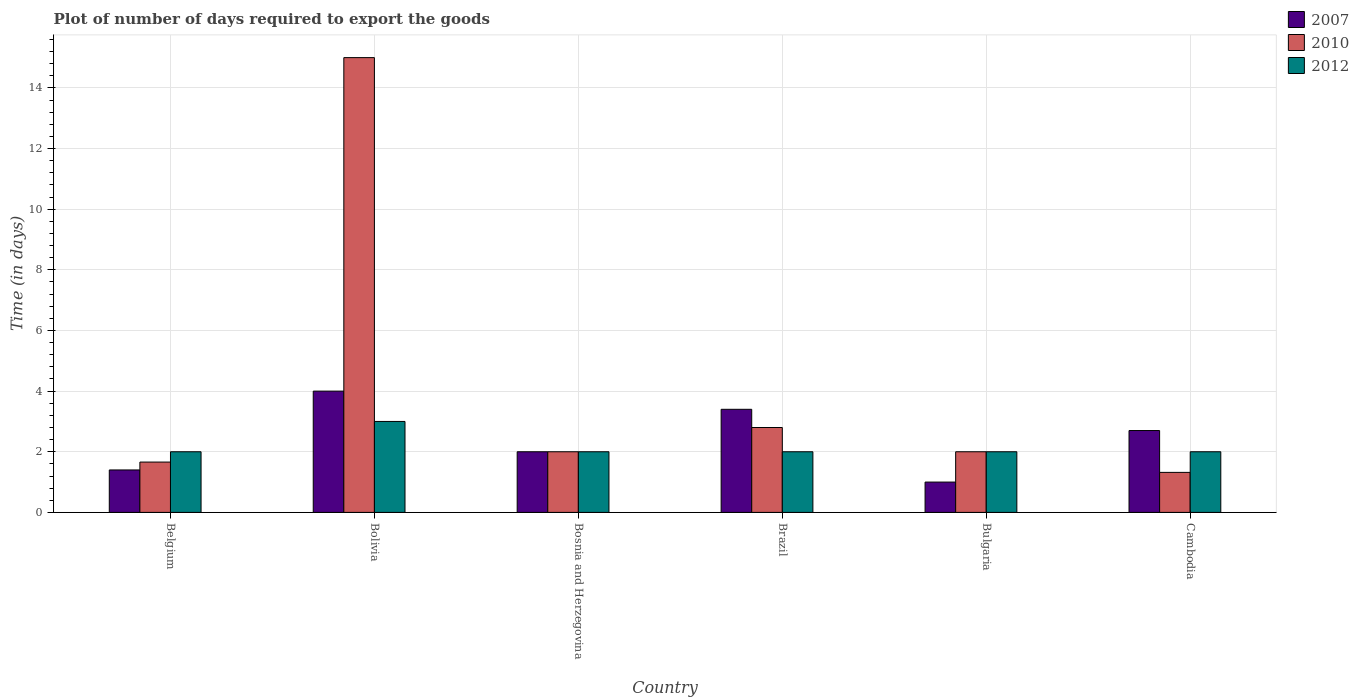Are the number of bars per tick equal to the number of legend labels?
Your answer should be compact. Yes. How many bars are there on the 5th tick from the right?
Give a very brief answer. 3. In how many cases, is the number of bars for a given country not equal to the number of legend labels?
Your answer should be very brief. 0. In which country was the time required to export goods in 2012 maximum?
Your answer should be very brief. Bolivia. In which country was the time required to export goods in 2007 minimum?
Keep it short and to the point. Bulgaria. What is the total time required to export goods in 2007 in the graph?
Your answer should be very brief. 14.5. What is the difference between the time required to export goods in 2012 in Belgium and that in Bolivia?
Provide a short and direct response. -1. What is the difference between the time required to export goods in 2007 in Cambodia and the time required to export goods in 2012 in Bulgaria?
Offer a very short reply. 0.7. What is the average time required to export goods in 2012 per country?
Your answer should be compact. 2.17. What is the difference between the time required to export goods of/in 2010 and time required to export goods of/in 2012 in Cambodia?
Offer a very short reply. -0.68. In how many countries, is the time required to export goods in 2010 greater than 2.8 days?
Make the answer very short. 1. What is the ratio of the time required to export goods in 2010 in Belgium to that in Bulgaria?
Your answer should be very brief. 0.83. Is the time required to export goods in 2007 in Belgium less than that in Bolivia?
Your answer should be compact. Yes. What is the difference between the highest and the lowest time required to export goods in 2010?
Make the answer very short. 13.68. Is the sum of the time required to export goods in 2012 in Bolivia and Brazil greater than the maximum time required to export goods in 2007 across all countries?
Your answer should be very brief. Yes. What does the 1st bar from the left in Bulgaria represents?
Offer a very short reply. 2007. What does the 3rd bar from the right in Bosnia and Herzegovina represents?
Your answer should be very brief. 2007. How many countries are there in the graph?
Ensure brevity in your answer.  6. What is the difference between two consecutive major ticks on the Y-axis?
Your response must be concise. 2. Are the values on the major ticks of Y-axis written in scientific E-notation?
Provide a succinct answer. No. Does the graph contain grids?
Provide a succinct answer. Yes. Where does the legend appear in the graph?
Offer a terse response. Top right. What is the title of the graph?
Offer a very short reply. Plot of number of days required to export the goods. Does "1967" appear as one of the legend labels in the graph?
Provide a succinct answer. No. What is the label or title of the X-axis?
Your response must be concise. Country. What is the label or title of the Y-axis?
Offer a terse response. Time (in days). What is the Time (in days) in 2007 in Belgium?
Your answer should be very brief. 1.4. What is the Time (in days) in 2010 in Belgium?
Your response must be concise. 1.66. What is the Time (in days) in 2012 in Belgium?
Ensure brevity in your answer.  2. What is the Time (in days) of 2007 in Bolivia?
Offer a terse response. 4. What is the Time (in days) of 2012 in Bolivia?
Provide a succinct answer. 3. What is the Time (in days) in 2007 in Brazil?
Give a very brief answer. 3.4. What is the Time (in days) of 2010 in Brazil?
Your answer should be very brief. 2.8. What is the Time (in days) of 2012 in Brazil?
Provide a short and direct response. 2. What is the Time (in days) of 2010 in Bulgaria?
Provide a short and direct response. 2. What is the Time (in days) in 2012 in Bulgaria?
Your answer should be compact. 2. What is the Time (in days) in 2007 in Cambodia?
Offer a terse response. 2.7. What is the Time (in days) in 2010 in Cambodia?
Your response must be concise. 1.32. What is the Time (in days) in 2012 in Cambodia?
Your answer should be compact. 2. Across all countries, what is the maximum Time (in days) of 2010?
Your answer should be very brief. 15. Across all countries, what is the minimum Time (in days) of 2010?
Provide a short and direct response. 1.32. Across all countries, what is the minimum Time (in days) of 2012?
Keep it short and to the point. 2. What is the total Time (in days) in 2007 in the graph?
Your answer should be very brief. 14.5. What is the total Time (in days) in 2010 in the graph?
Your answer should be compact. 24.78. What is the difference between the Time (in days) of 2007 in Belgium and that in Bolivia?
Make the answer very short. -2.6. What is the difference between the Time (in days) of 2010 in Belgium and that in Bolivia?
Ensure brevity in your answer.  -13.34. What is the difference between the Time (in days) in 2012 in Belgium and that in Bolivia?
Make the answer very short. -1. What is the difference between the Time (in days) in 2007 in Belgium and that in Bosnia and Herzegovina?
Ensure brevity in your answer.  -0.6. What is the difference between the Time (in days) of 2010 in Belgium and that in Bosnia and Herzegovina?
Keep it short and to the point. -0.34. What is the difference between the Time (in days) in 2010 in Belgium and that in Brazil?
Give a very brief answer. -1.14. What is the difference between the Time (in days) in 2010 in Belgium and that in Bulgaria?
Give a very brief answer. -0.34. What is the difference between the Time (in days) in 2010 in Belgium and that in Cambodia?
Give a very brief answer. 0.34. What is the difference between the Time (in days) in 2012 in Belgium and that in Cambodia?
Your answer should be compact. 0. What is the difference between the Time (in days) in 2007 in Bolivia and that in Bosnia and Herzegovina?
Your answer should be very brief. 2. What is the difference between the Time (in days) of 2010 in Bolivia and that in Bosnia and Herzegovina?
Offer a terse response. 13. What is the difference between the Time (in days) of 2007 in Bolivia and that in Brazil?
Make the answer very short. 0.6. What is the difference between the Time (in days) of 2010 in Bolivia and that in Brazil?
Your answer should be compact. 12.2. What is the difference between the Time (in days) of 2010 in Bolivia and that in Cambodia?
Your answer should be compact. 13.68. What is the difference between the Time (in days) of 2012 in Bolivia and that in Cambodia?
Provide a succinct answer. 1. What is the difference between the Time (in days) in 2010 in Bosnia and Herzegovina and that in Brazil?
Keep it short and to the point. -0.8. What is the difference between the Time (in days) of 2010 in Bosnia and Herzegovina and that in Cambodia?
Make the answer very short. 0.68. What is the difference between the Time (in days) in 2012 in Bosnia and Herzegovina and that in Cambodia?
Provide a short and direct response. 0. What is the difference between the Time (in days) of 2010 in Brazil and that in Bulgaria?
Offer a very short reply. 0.8. What is the difference between the Time (in days) in 2012 in Brazil and that in Bulgaria?
Provide a succinct answer. 0. What is the difference between the Time (in days) in 2010 in Brazil and that in Cambodia?
Your answer should be very brief. 1.48. What is the difference between the Time (in days) of 2007 in Bulgaria and that in Cambodia?
Your answer should be very brief. -1.7. What is the difference between the Time (in days) of 2010 in Bulgaria and that in Cambodia?
Provide a short and direct response. 0.68. What is the difference between the Time (in days) in 2010 in Belgium and the Time (in days) in 2012 in Bolivia?
Ensure brevity in your answer.  -1.34. What is the difference between the Time (in days) in 2007 in Belgium and the Time (in days) in 2010 in Bosnia and Herzegovina?
Offer a terse response. -0.6. What is the difference between the Time (in days) of 2007 in Belgium and the Time (in days) of 2012 in Bosnia and Herzegovina?
Your response must be concise. -0.6. What is the difference between the Time (in days) of 2010 in Belgium and the Time (in days) of 2012 in Bosnia and Herzegovina?
Make the answer very short. -0.34. What is the difference between the Time (in days) in 2010 in Belgium and the Time (in days) in 2012 in Brazil?
Give a very brief answer. -0.34. What is the difference between the Time (in days) of 2010 in Belgium and the Time (in days) of 2012 in Bulgaria?
Provide a short and direct response. -0.34. What is the difference between the Time (in days) in 2010 in Belgium and the Time (in days) in 2012 in Cambodia?
Make the answer very short. -0.34. What is the difference between the Time (in days) of 2007 in Bolivia and the Time (in days) of 2010 in Bosnia and Herzegovina?
Give a very brief answer. 2. What is the difference between the Time (in days) of 2007 in Bolivia and the Time (in days) of 2012 in Bosnia and Herzegovina?
Ensure brevity in your answer.  2. What is the difference between the Time (in days) in 2007 in Bolivia and the Time (in days) in 2012 in Brazil?
Offer a terse response. 2. What is the difference between the Time (in days) of 2010 in Bolivia and the Time (in days) of 2012 in Brazil?
Provide a succinct answer. 13. What is the difference between the Time (in days) of 2007 in Bolivia and the Time (in days) of 2010 in Cambodia?
Give a very brief answer. 2.68. What is the difference between the Time (in days) of 2007 in Bolivia and the Time (in days) of 2012 in Cambodia?
Your answer should be very brief. 2. What is the difference between the Time (in days) in 2010 in Bolivia and the Time (in days) in 2012 in Cambodia?
Give a very brief answer. 13. What is the difference between the Time (in days) of 2010 in Bosnia and Herzegovina and the Time (in days) of 2012 in Brazil?
Make the answer very short. 0. What is the difference between the Time (in days) of 2010 in Bosnia and Herzegovina and the Time (in days) of 2012 in Bulgaria?
Provide a succinct answer. 0. What is the difference between the Time (in days) in 2007 in Bosnia and Herzegovina and the Time (in days) in 2010 in Cambodia?
Keep it short and to the point. 0.68. What is the difference between the Time (in days) of 2007 in Brazil and the Time (in days) of 2010 in Bulgaria?
Your answer should be compact. 1.4. What is the difference between the Time (in days) of 2010 in Brazil and the Time (in days) of 2012 in Bulgaria?
Your answer should be very brief. 0.8. What is the difference between the Time (in days) in 2007 in Brazil and the Time (in days) in 2010 in Cambodia?
Your answer should be very brief. 2.08. What is the difference between the Time (in days) of 2010 in Brazil and the Time (in days) of 2012 in Cambodia?
Offer a very short reply. 0.8. What is the difference between the Time (in days) of 2007 in Bulgaria and the Time (in days) of 2010 in Cambodia?
Provide a short and direct response. -0.32. What is the average Time (in days) in 2007 per country?
Give a very brief answer. 2.42. What is the average Time (in days) of 2010 per country?
Offer a terse response. 4.13. What is the average Time (in days) in 2012 per country?
Provide a short and direct response. 2.17. What is the difference between the Time (in days) in 2007 and Time (in days) in 2010 in Belgium?
Make the answer very short. -0.26. What is the difference between the Time (in days) of 2010 and Time (in days) of 2012 in Belgium?
Make the answer very short. -0.34. What is the difference between the Time (in days) in 2007 and Time (in days) in 2010 in Bolivia?
Offer a very short reply. -11. What is the difference between the Time (in days) in 2007 and Time (in days) in 2010 in Bosnia and Herzegovina?
Keep it short and to the point. 0. What is the difference between the Time (in days) in 2007 and Time (in days) in 2012 in Bosnia and Herzegovina?
Offer a very short reply. 0. What is the difference between the Time (in days) in 2010 and Time (in days) in 2012 in Brazil?
Ensure brevity in your answer.  0.8. What is the difference between the Time (in days) in 2007 and Time (in days) in 2010 in Bulgaria?
Offer a terse response. -1. What is the difference between the Time (in days) of 2007 and Time (in days) of 2012 in Bulgaria?
Provide a succinct answer. -1. What is the difference between the Time (in days) in 2007 and Time (in days) in 2010 in Cambodia?
Your response must be concise. 1.38. What is the difference between the Time (in days) of 2007 and Time (in days) of 2012 in Cambodia?
Your answer should be compact. 0.7. What is the difference between the Time (in days) in 2010 and Time (in days) in 2012 in Cambodia?
Provide a succinct answer. -0.68. What is the ratio of the Time (in days) of 2007 in Belgium to that in Bolivia?
Your response must be concise. 0.35. What is the ratio of the Time (in days) in 2010 in Belgium to that in Bolivia?
Provide a short and direct response. 0.11. What is the ratio of the Time (in days) in 2012 in Belgium to that in Bolivia?
Offer a very short reply. 0.67. What is the ratio of the Time (in days) of 2010 in Belgium to that in Bosnia and Herzegovina?
Provide a short and direct response. 0.83. What is the ratio of the Time (in days) of 2012 in Belgium to that in Bosnia and Herzegovina?
Give a very brief answer. 1. What is the ratio of the Time (in days) in 2007 in Belgium to that in Brazil?
Give a very brief answer. 0.41. What is the ratio of the Time (in days) of 2010 in Belgium to that in Brazil?
Give a very brief answer. 0.59. What is the ratio of the Time (in days) of 2010 in Belgium to that in Bulgaria?
Give a very brief answer. 0.83. What is the ratio of the Time (in days) in 2012 in Belgium to that in Bulgaria?
Offer a very short reply. 1. What is the ratio of the Time (in days) in 2007 in Belgium to that in Cambodia?
Offer a very short reply. 0.52. What is the ratio of the Time (in days) in 2010 in Belgium to that in Cambodia?
Make the answer very short. 1.26. What is the ratio of the Time (in days) in 2012 in Belgium to that in Cambodia?
Your response must be concise. 1. What is the ratio of the Time (in days) in 2007 in Bolivia to that in Bosnia and Herzegovina?
Provide a short and direct response. 2. What is the ratio of the Time (in days) of 2012 in Bolivia to that in Bosnia and Herzegovina?
Provide a succinct answer. 1.5. What is the ratio of the Time (in days) in 2007 in Bolivia to that in Brazil?
Give a very brief answer. 1.18. What is the ratio of the Time (in days) of 2010 in Bolivia to that in Brazil?
Ensure brevity in your answer.  5.36. What is the ratio of the Time (in days) of 2012 in Bolivia to that in Brazil?
Make the answer very short. 1.5. What is the ratio of the Time (in days) in 2007 in Bolivia to that in Bulgaria?
Your answer should be very brief. 4. What is the ratio of the Time (in days) of 2010 in Bolivia to that in Bulgaria?
Your answer should be very brief. 7.5. What is the ratio of the Time (in days) of 2012 in Bolivia to that in Bulgaria?
Make the answer very short. 1.5. What is the ratio of the Time (in days) in 2007 in Bolivia to that in Cambodia?
Offer a terse response. 1.48. What is the ratio of the Time (in days) of 2010 in Bolivia to that in Cambodia?
Offer a very short reply. 11.36. What is the ratio of the Time (in days) of 2007 in Bosnia and Herzegovina to that in Brazil?
Provide a short and direct response. 0.59. What is the ratio of the Time (in days) of 2010 in Bosnia and Herzegovina to that in Brazil?
Ensure brevity in your answer.  0.71. What is the ratio of the Time (in days) of 2007 in Bosnia and Herzegovina to that in Bulgaria?
Provide a succinct answer. 2. What is the ratio of the Time (in days) in 2010 in Bosnia and Herzegovina to that in Bulgaria?
Provide a short and direct response. 1. What is the ratio of the Time (in days) of 2007 in Bosnia and Herzegovina to that in Cambodia?
Offer a very short reply. 0.74. What is the ratio of the Time (in days) in 2010 in Bosnia and Herzegovina to that in Cambodia?
Make the answer very short. 1.52. What is the ratio of the Time (in days) of 2012 in Bosnia and Herzegovina to that in Cambodia?
Provide a succinct answer. 1. What is the ratio of the Time (in days) in 2012 in Brazil to that in Bulgaria?
Keep it short and to the point. 1. What is the ratio of the Time (in days) of 2007 in Brazil to that in Cambodia?
Your answer should be compact. 1.26. What is the ratio of the Time (in days) in 2010 in Brazil to that in Cambodia?
Offer a terse response. 2.12. What is the ratio of the Time (in days) in 2007 in Bulgaria to that in Cambodia?
Keep it short and to the point. 0.37. What is the ratio of the Time (in days) in 2010 in Bulgaria to that in Cambodia?
Your answer should be very brief. 1.52. What is the difference between the highest and the second highest Time (in days) in 2007?
Ensure brevity in your answer.  0.6. What is the difference between the highest and the second highest Time (in days) of 2010?
Ensure brevity in your answer.  12.2. What is the difference between the highest and the lowest Time (in days) of 2010?
Provide a short and direct response. 13.68. What is the difference between the highest and the lowest Time (in days) of 2012?
Offer a very short reply. 1. 